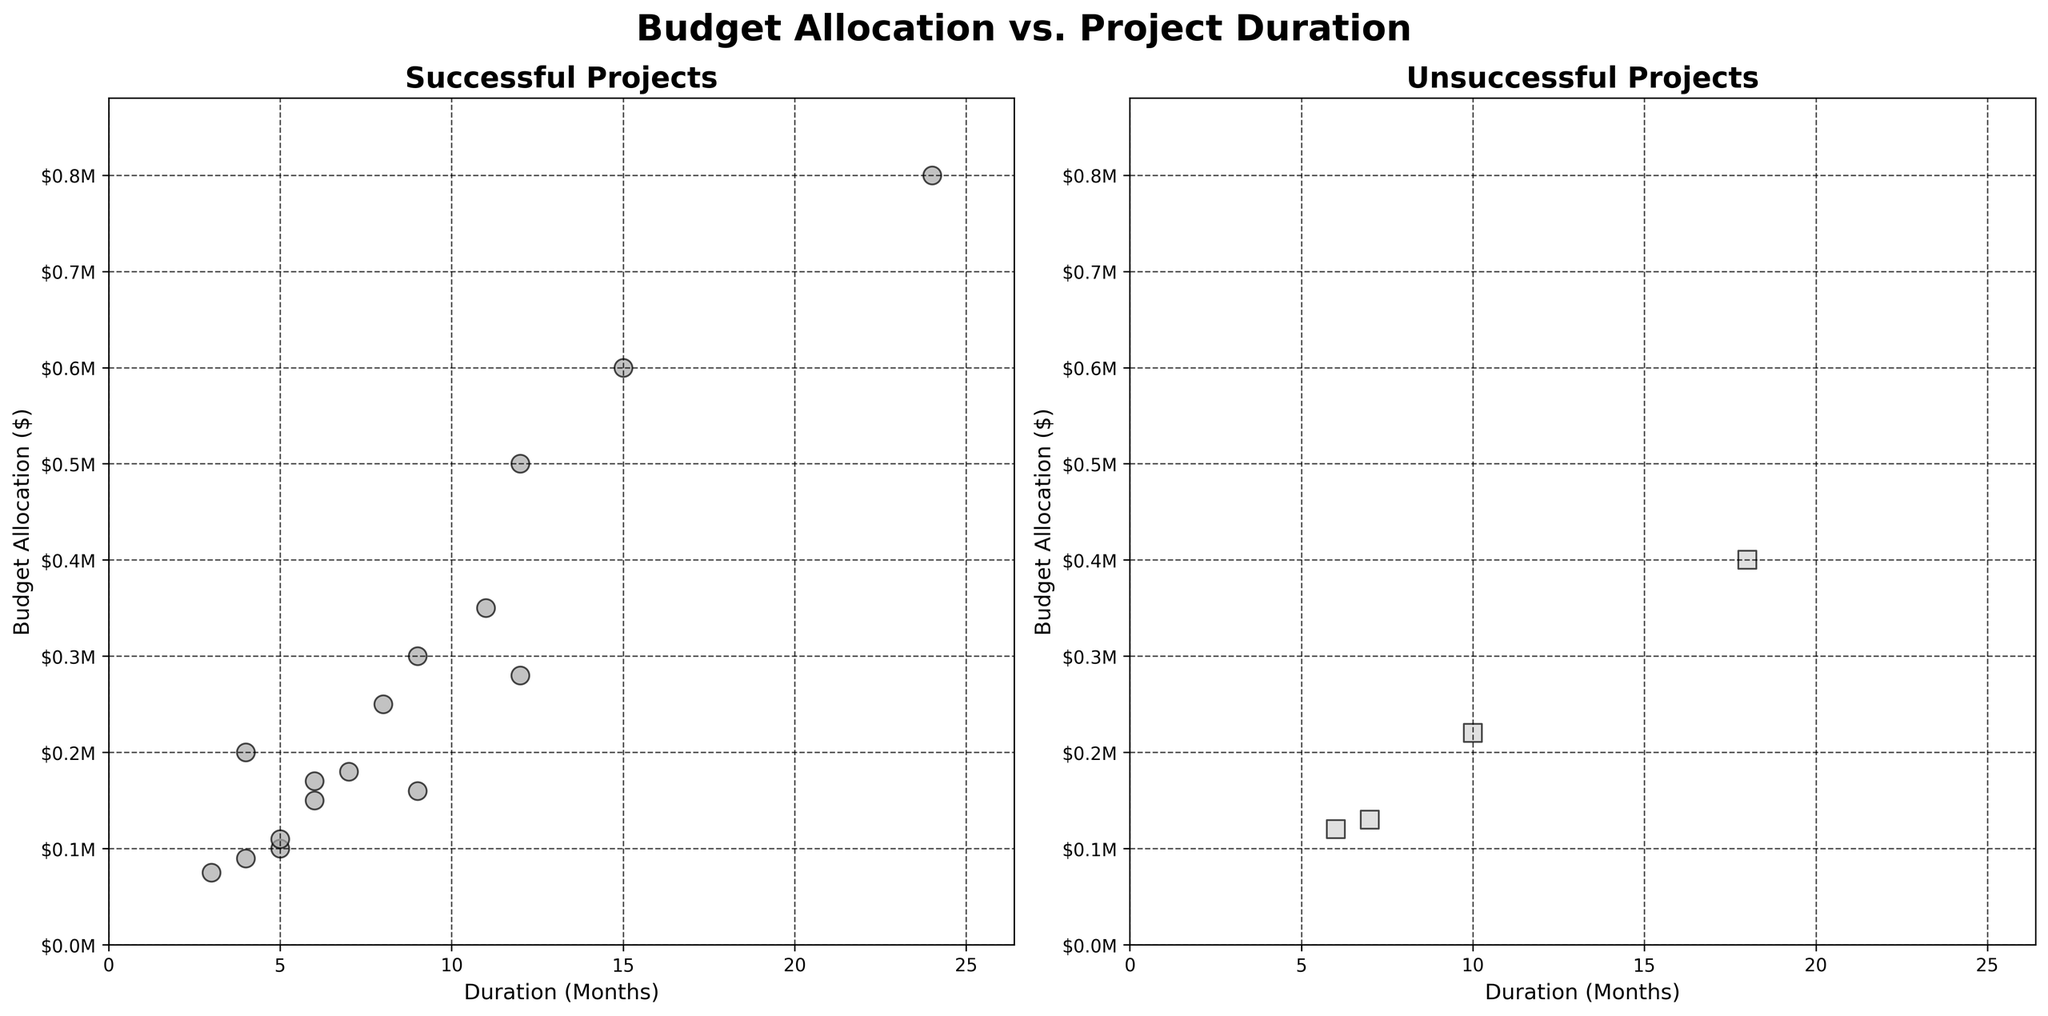What are the title and axis labels in the figure? The title of the figure is "Budget Allocation vs. Project Duration". The x-axis label in both subplots is "Duration (Months)" and the y-axis label is "Budget Allocation ($)".
Answer: "Budget Allocation vs. Project Duration", "Duration (Months)", "Budget Allocation ($)" How many data points are shown for successful projects? Count the number of markers in the subplot for successful projects. There are 15 markers (circles) in the "Successful Projects" subplot.
Answer: 15 How many unsuccessful projects have a duration greater than 12 months? Identify markers (squares) in the "Unsuccessful Projects" subplot that are located to the right of the 12-month mark on the x-axis. Three projects fit this criterion.
Answer: 3 What is the maximum budget allocated to successful projects? Look at the highest position of the markers (circles) along the y-axis in the "Successful Projects" subplot. The highest budget allocated is $800,000.
Answer: $800,000 Compare the project duration of the most expensive successful project and the most expensive unsuccessful project. Which one has a longer duration? The most expensive successful project is allocated $800,000 with a duration of 24 months. The most expensive unsuccessful project is allocated $400,000 with a duration of 18 months. Therefore, the successful project has a longer duration.
Answer: Successful project What is the total number of unsuccessful projects that have a budget allocation below $200,000? Identify markers (squares) in the "Unsuccessful Projects" subplot that are located below the $200,000 position on the y-axis. There are three such projects.
Answer: 3 For successful projects, what is the average duration? Sum the durations of all successful projects and divide by the number of successful projects: (6+12+9+4+3+5+8+7+24+4+9+15+11+12+5)/15 = 10.07 months (rounded to two decimal places).
Answer: 10.07 months Is there any unsuccessful project with a budget allocation higher than any successful project? Compare the highest budget allocation of unsuccessful projects ($400,000) with the lowest budget allocation of successful projects ($75,000). Since $400,000 is not higher than any successful project budget, the answer is no.
Answer: No What is the relationship between budget allocation and project duration in unsuccessful projects compared to successful projects? Both subplots show the distribution of budget allocation versus project duration. Unsuccessful projects tend to have both lower budget allocations and shorter durations compared to successful projects, but there isn't a clear linear relationship visible in either subplot.
Answer: Unsuccessful projects tend to have lower budgets and shorter durations What is the highest budget allocation for a project within 6 months duration, and is it successful or unsuccessful? Look at both subplots for projects at or below the 6-month mark on the x-axis and identify the highest y-axis positions. The project with the highest budget allocation within 6 months is $170,000 for a successful project.
Answer: $170,000, Successful 